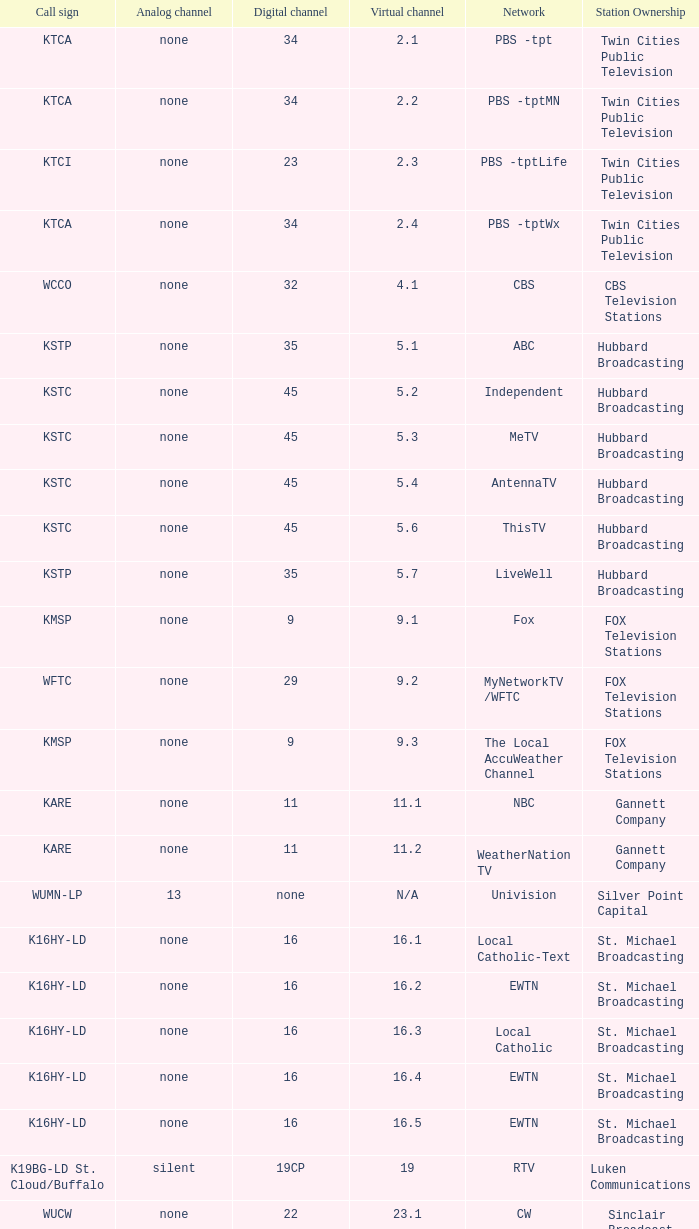What is the call sign for virtual channel 1 K16HY-LD. 